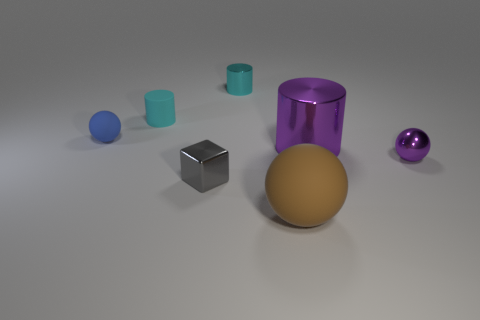Subtract all shiny cylinders. How many cylinders are left? 1 Subtract all blue balls. How many cyan cylinders are left? 2 Add 1 big metallic spheres. How many objects exist? 8 Subtract 1 cylinders. How many cylinders are left? 2 Subtract all blocks. How many objects are left? 6 Subtract all red cylinders. Subtract all cyan blocks. How many cylinders are left? 3 Subtract all small things. Subtract all brown balls. How many objects are left? 1 Add 4 tiny rubber things. How many tiny rubber things are left? 6 Add 1 small cyan rubber blocks. How many small cyan rubber blocks exist? 1 Subtract 1 blue balls. How many objects are left? 6 